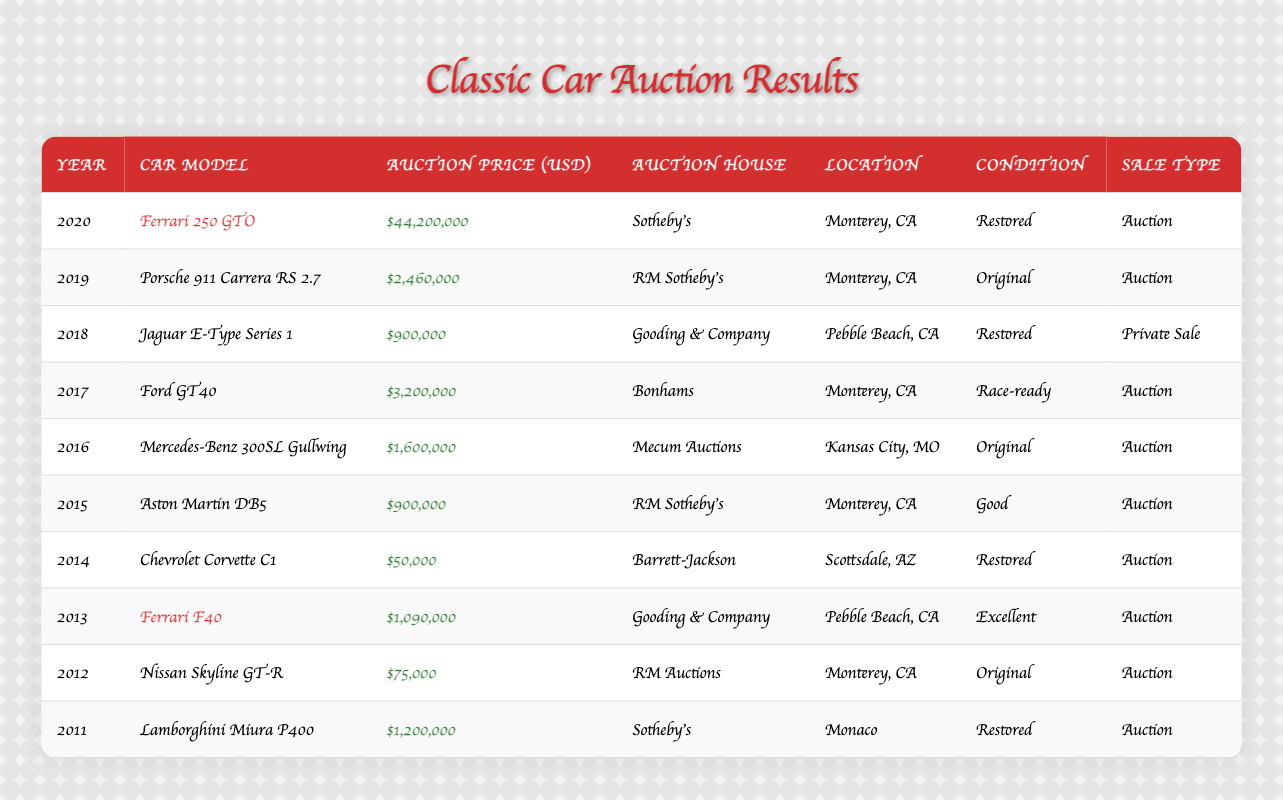What is the highest auction price recorded in the table? The highest auction price is found by scanning through the "Auction Price (USD)" column. The maximum value listed is $44,200,000 for the Ferrari 250 GTO in 2020.
Answer: $44,200,000 Which car was sold for the lowest price? By reviewing the "Auction Price (USD)" column, the car with the lowest auction price is the Chevrolet Corvette C1 from 2014, which sold for $50,000.
Answer: $50,000 How many Ferrari models are listed in the table? The table shows two Ferrari models: the Ferrari 250 GTO from 2020 and the Ferrari F40 from 2013. Counting these models gives a total of 2.
Answer: 2 What is the average auction price of all cars sold? First, we sum all the auction prices: $44,200,000 + $2,460,000 + $900,000 + $3,200,000 + $1,600,000 + $900,000 + $50,000 + $1,090,000 + $75,000 + $1,200,000 = $55,075,000. There are 10 cars, so we divide $55,075,000 by 10 to find the average, which equals $5,507,500.
Answer: $5,507,500 Which auction house sold the most expensive car? To determine this, we need to identify the highest price car and check which auction house it was sold at. The highest price was for the Ferrari 250 GTO at Sotheby's, thus making Sotheby's the auction house with the most expensive car.
Answer: Sotheby's How many cars were in "Restored" condition at the auction? By checking each condition listed in the table, we find that there are 5 cars listed as "Restored"—Ferrari 250 GTO, Jaguar E-Type Series 1, Chevrolet Corvette C1, Lamborghini Miura P400, and Ford GT40.
Answer: 5 Was there a car sold at auction in 2014? By looking at the year column, we see that the Chevrolet Corvette C1 was sold in 2014 at auction according to the “Sale Type” column showing "Auction." Therefore, the answer is yes.
Answer: Yes What is the total auction price of cars sold in 2019 and 2020? The auction prices for 2019 and 2020 are $2,460,000 (2019) and $44,200,000 (2020) respectively. Adding these together gives $2,460,000 + $44,200,000 = $46,660,000.
Answer: $46,660,000 How many of the cars were sold for over 1 million USD? We identify the prices over 1 million USD: Ferrari 250 GTO ($44,200,000), Porsche 911 Carrera RS 2.7 ($2,460,000), Ford GT40 ($3,200,000), and Lamborghini Miura P400 ($1,200,000). Counting these, there are 4 cars.
Answer: 4 Which car had a sale type of "Private Sale"? Only one entry has the sale type labeled as "Private Sale," which is the Jaguar E-Type Series 1 from 2018.
Answer: Jaguar E-Type Series 1 Which location had the most auctions listed? By analyzing the "Location" column, Monterey, CA appears three times (2020, 2019, 2017), making it the location with the most auctions in this table.
Answer: Monterey, CA 